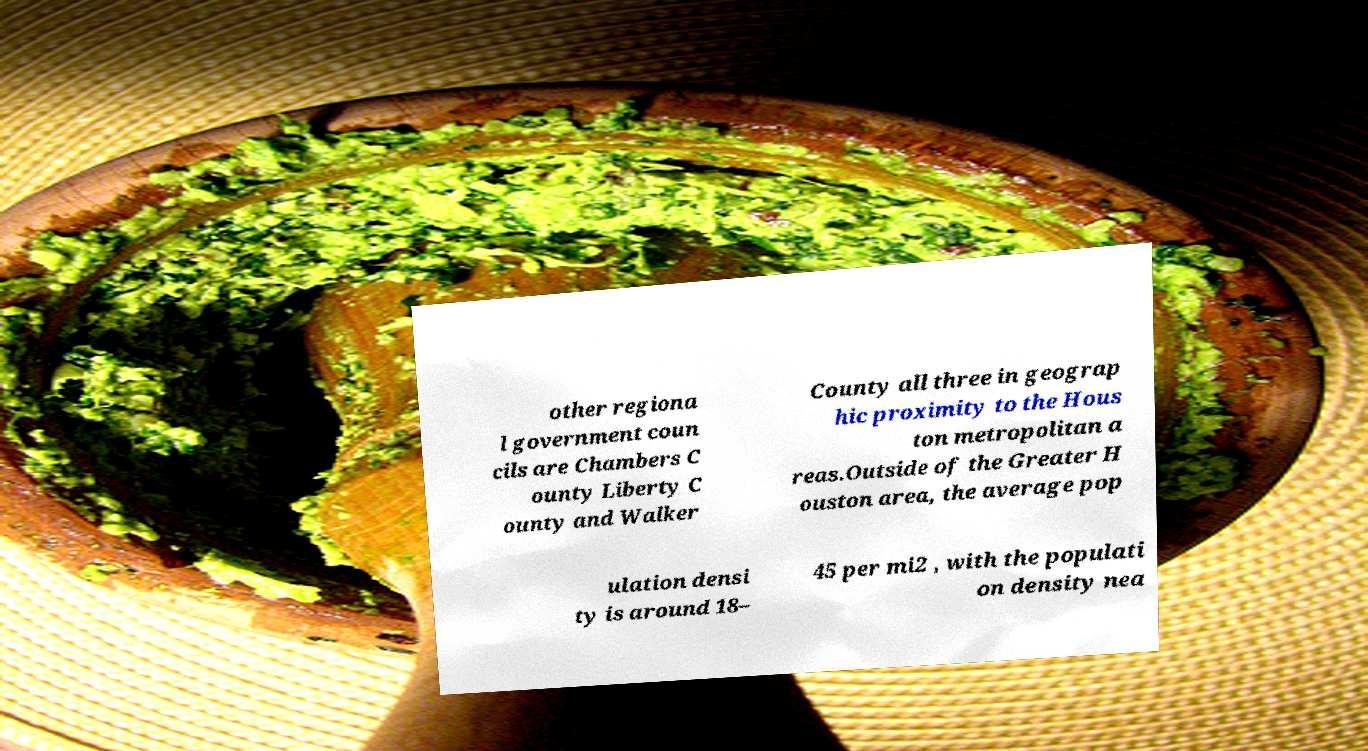Please identify and transcribe the text found in this image. other regiona l government coun cils are Chambers C ounty Liberty C ounty and Walker County all three in geograp hic proximity to the Hous ton metropolitan a reas.Outside of the Greater H ouston area, the average pop ulation densi ty is around 18– 45 per mi2 , with the populati on density nea 